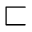Convert formula to latex. <formula><loc_0><loc_0><loc_500><loc_500>\sqsubset</formula> 